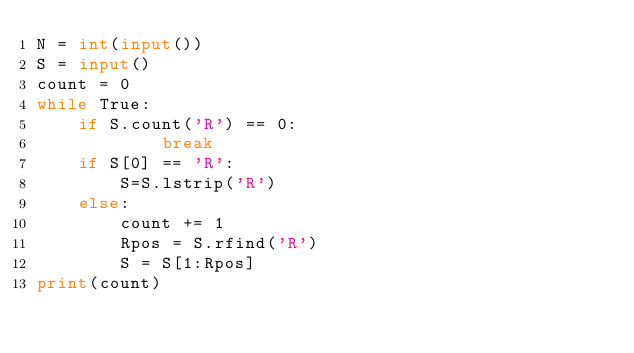<code> <loc_0><loc_0><loc_500><loc_500><_Python_>N = int(input())
S = input()
count = 0
while True:
	if S.count('R') == 0:
			break
	if S[0] == 'R':
		S=S.lstrip('R')
	else:
		count += 1
		Rpos = S.rfind('R')
		S = S[1:Rpos]
print(count)
</code> 